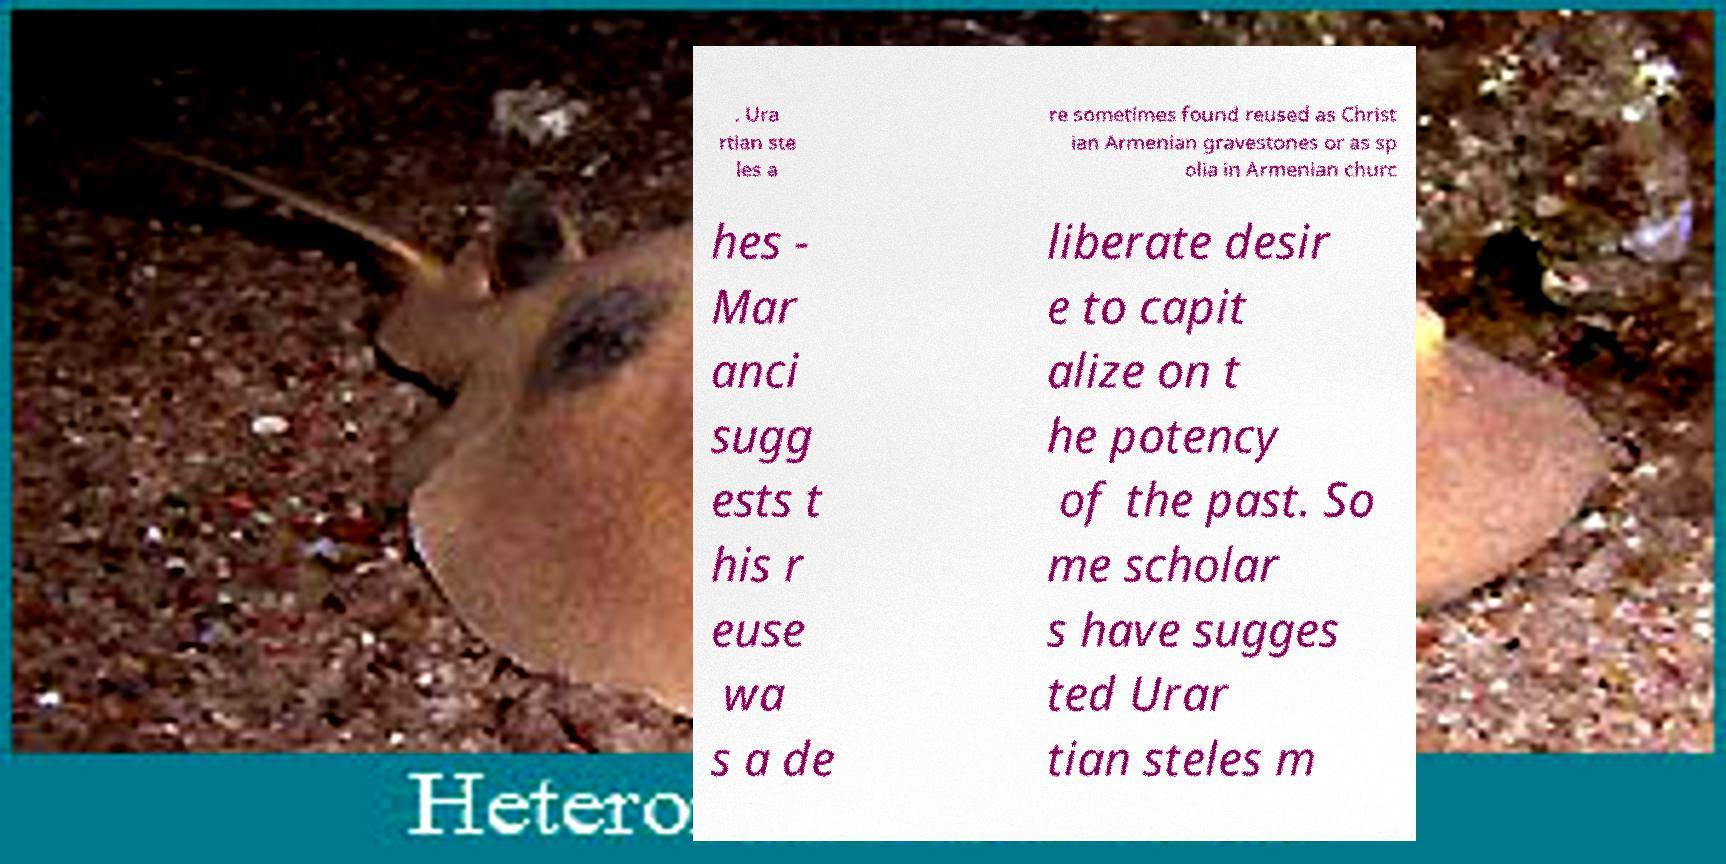There's text embedded in this image that I need extracted. Can you transcribe it verbatim? . Ura rtian ste les a re sometimes found reused as Christ ian Armenian gravestones or as sp olia in Armenian churc hes - Mar anci sugg ests t his r euse wa s a de liberate desir e to capit alize on t he potency of the past. So me scholar s have sugges ted Urar tian steles m 